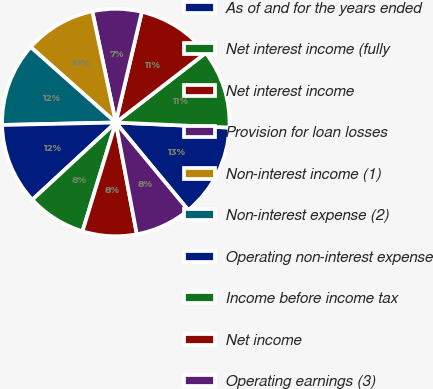Convert chart. <chart><loc_0><loc_0><loc_500><loc_500><pie_chart><fcel>As of and for the years ended<fcel>Net interest income (fully<fcel>Net interest income<fcel>Provision for loan losses<fcel>Non-interest income (1)<fcel>Non-interest expense (2)<fcel>Operating non-interest expense<fcel>Income before income tax<fcel>Net income<fcel>Operating earnings (3)<nl><fcel>13.29%<fcel>11.19%<fcel>10.84%<fcel>6.99%<fcel>10.14%<fcel>11.89%<fcel>11.54%<fcel>8.39%<fcel>7.69%<fcel>8.04%<nl></chart> 